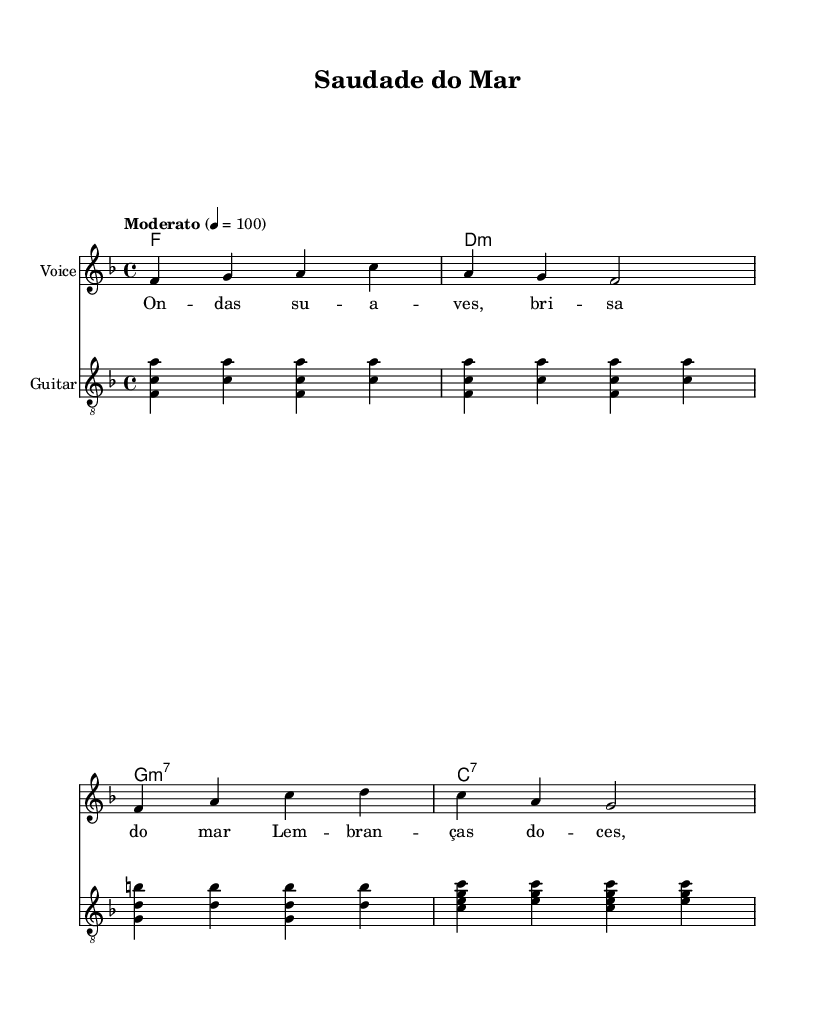What is the key signature of this music? The key signature indicated in the music is F major, which has one flat. This is determined by the key signature placed at the beginning of the score.
Answer: F major What is the time signature of this piece? The time signature shown in the music is 4/4, meaning there are four beats per measure and the quarter note gets one beat. This is indicated at the start of the score.
Answer: 4/4 What is the tempo marking for this composition? The tempo marking is marked as "Moderato," which refers to a moderate speed, and is set to 100 beats per minute, as indicated in the tempo section of the score.
Answer: Moderato How many measures does the melody have? By counting the distinct groupings of notes separated by the vertical lines (bars), the melody has a total of four measures.
Answer: 4 What type of harmony is first present in the piece? The first harmony indicated is an F major chord, as shown in the chord symbols placed above the staff at the beginning of the score.
Answer: F What instrument does the score specify for the guitar? The score explicitly names the instrument for the guitar as "Guitar," which is shown at the top of the guitar staff, indicating the type of instrumental accompaniment.
Answer: Guitar What does "clef treble_8" imply in this score? The "clef treble_8" means the guitar part is written in the treble clef but sounds an octave lower than notated, which is common for guitar music. This is indicated by the clef marking in the guitar staff.
Answer: Treble clef 